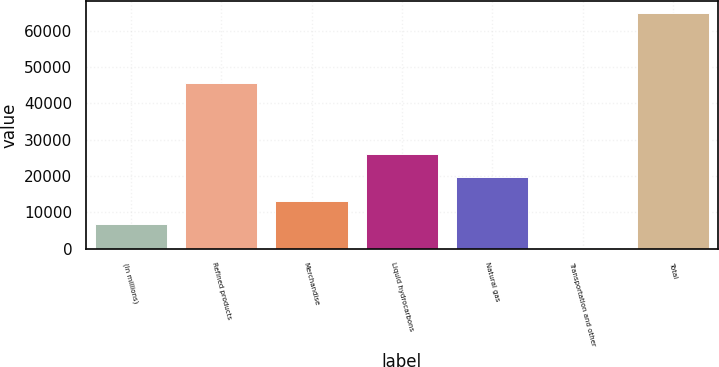Convert chart. <chart><loc_0><loc_0><loc_500><loc_500><bar_chart><fcel>(In millions)<fcel>Refined products<fcel>Merchandise<fcel>Liquid hydrocarbons<fcel>Natural gas<fcel>Transportation and other<fcel>Total<nl><fcel>6706.5<fcel>45511<fcel>13172<fcel>26103<fcel>19637.5<fcel>241<fcel>64896<nl></chart> 